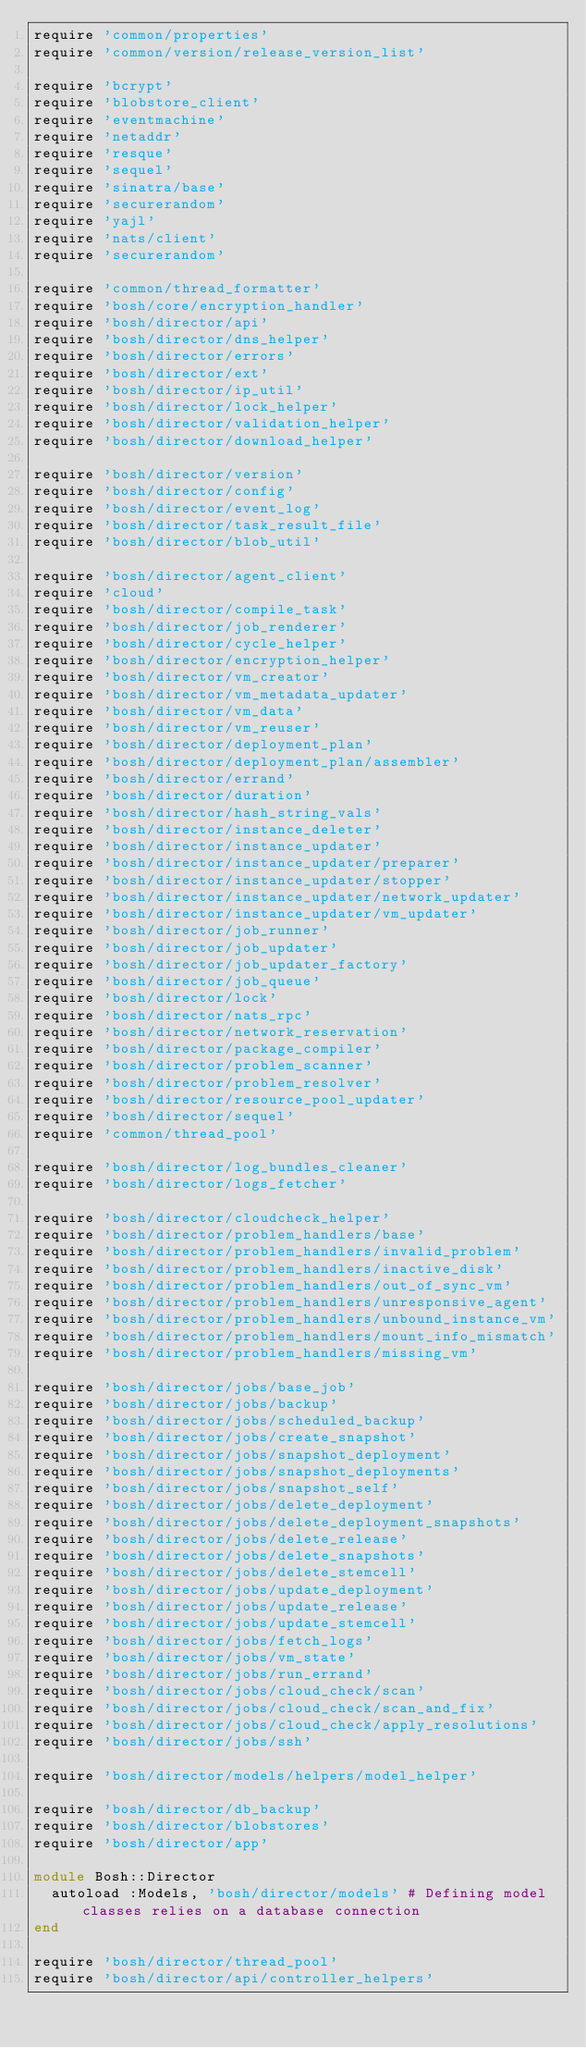<code> <loc_0><loc_0><loc_500><loc_500><_Ruby_>require 'common/properties'
require 'common/version/release_version_list'

require 'bcrypt'
require 'blobstore_client'
require 'eventmachine'
require 'netaddr'
require 'resque'
require 'sequel'
require 'sinatra/base'
require 'securerandom'
require 'yajl'
require 'nats/client'
require 'securerandom'

require 'common/thread_formatter'
require 'bosh/core/encryption_handler'
require 'bosh/director/api'
require 'bosh/director/dns_helper'
require 'bosh/director/errors'
require 'bosh/director/ext'
require 'bosh/director/ip_util'
require 'bosh/director/lock_helper'
require 'bosh/director/validation_helper'
require 'bosh/director/download_helper'

require 'bosh/director/version'
require 'bosh/director/config'
require 'bosh/director/event_log'
require 'bosh/director/task_result_file'
require 'bosh/director/blob_util'

require 'bosh/director/agent_client'
require 'cloud'
require 'bosh/director/compile_task'
require 'bosh/director/job_renderer'
require 'bosh/director/cycle_helper'
require 'bosh/director/encryption_helper'
require 'bosh/director/vm_creator'
require 'bosh/director/vm_metadata_updater'
require 'bosh/director/vm_data'
require 'bosh/director/vm_reuser'
require 'bosh/director/deployment_plan'
require 'bosh/director/deployment_plan/assembler'
require 'bosh/director/errand'
require 'bosh/director/duration'
require 'bosh/director/hash_string_vals'
require 'bosh/director/instance_deleter'
require 'bosh/director/instance_updater'
require 'bosh/director/instance_updater/preparer'
require 'bosh/director/instance_updater/stopper'
require 'bosh/director/instance_updater/network_updater'
require 'bosh/director/instance_updater/vm_updater'
require 'bosh/director/job_runner'
require 'bosh/director/job_updater'
require 'bosh/director/job_updater_factory'
require 'bosh/director/job_queue'
require 'bosh/director/lock'
require 'bosh/director/nats_rpc'
require 'bosh/director/network_reservation'
require 'bosh/director/package_compiler'
require 'bosh/director/problem_scanner'
require 'bosh/director/problem_resolver'
require 'bosh/director/resource_pool_updater'
require 'bosh/director/sequel'
require 'common/thread_pool'

require 'bosh/director/log_bundles_cleaner'
require 'bosh/director/logs_fetcher'

require 'bosh/director/cloudcheck_helper'
require 'bosh/director/problem_handlers/base'
require 'bosh/director/problem_handlers/invalid_problem'
require 'bosh/director/problem_handlers/inactive_disk'
require 'bosh/director/problem_handlers/out_of_sync_vm'
require 'bosh/director/problem_handlers/unresponsive_agent'
require 'bosh/director/problem_handlers/unbound_instance_vm'
require 'bosh/director/problem_handlers/mount_info_mismatch'
require 'bosh/director/problem_handlers/missing_vm'

require 'bosh/director/jobs/base_job'
require 'bosh/director/jobs/backup'
require 'bosh/director/jobs/scheduled_backup'
require 'bosh/director/jobs/create_snapshot'
require 'bosh/director/jobs/snapshot_deployment'
require 'bosh/director/jobs/snapshot_deployments'
require 'bosh/director/jobs/snapshot_self'
require 'bosh/director/jobs/delete_deployment'
require 'bosh/director/jobs/delete_deployment_snapshots'
require 'bosh/director/jobs/delete_release'
require 'bosh/director/jobs/delete_snapshots'
require 'bosh/director/jobs/delete_stemcell'
require 'bosh/director/jobs/update_deployment'
require 'bosh/director/jobs/update_release'
require 'bosh/director/jobs/update_stemcell'
require 'bosh/director/jobs/fetch_logs'
require 'bosh/director/jobs/vm_state'
require 'bosh/director/jobs/run_errand'
require 'bosh/director/jobs/cloud_check/scan'
require 'bosh/director/jobs/cloud_check/scan_and_fix'
require 'bosh/director/jobs/cloud_check/apply_resolutions'
require 'bosh/director/jobs/ssh'

require 'bosh/director/models/helpers/model_helper'

require 'bosh/director/db_backup'
require 'bosh/director/blobstores'
require 'bosh/director/app'

module Bosh::Director
  autoload :Models, 'bosh/director/models' # Defining model classes relies on a database connection
end

require 'bosh/director/thread_pool'
require 'bosh/director/api/controller_helpers'</code> 